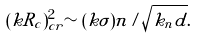Convert formula to latex. <formula><loc_0><loc_0><loc_500><loc_500>( k R _ { c } ) _ { c r } ^ { 2 } \sim ( k \sigma ) n / \sqrt { k _ { n } d } .</formula> 